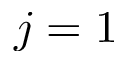<formula> <loc_0><loc_0><loc_500><loc_500>j = 1</formula> 